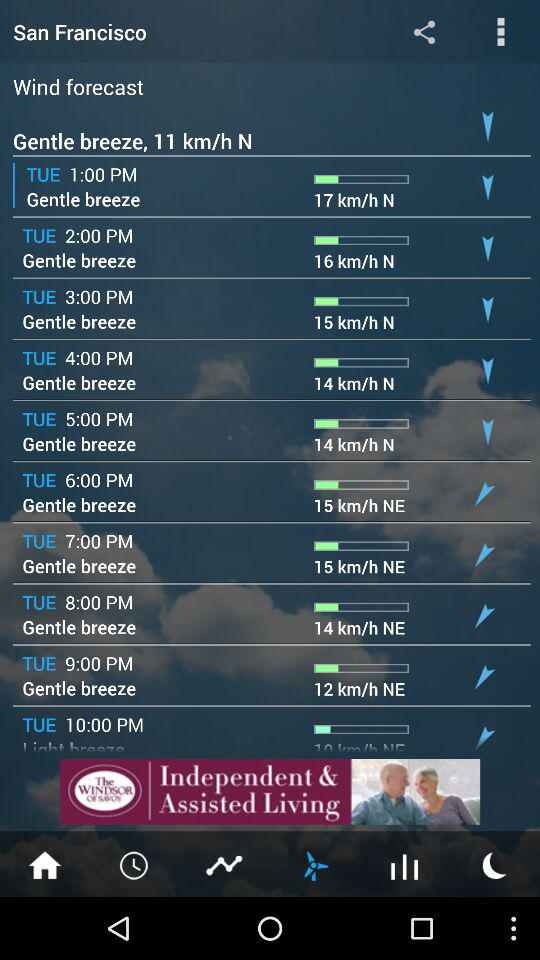What is the mentioned city? The mentioned city is San Francisco. 